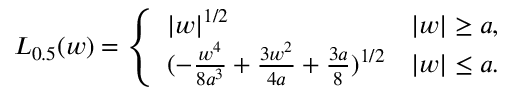<formula> <loc_0><loc_0><loc_500><loc_500>L _ { 0 . 5 } ( w ) = \left \{ \begin{array} { l r } { | w | ^ { 1 / 2 } } & { | w | \geq a , } \\ { ( - \frac { w ^ { 4 } } { 8 a ^ { 3 } } + \frac { 3 w ^ { 2 } } { 4 a } + \frac { 3 a } { 8 } ) ^ { 1 / 2 } } & { | w | \leq a . } \end{array}</formula> 